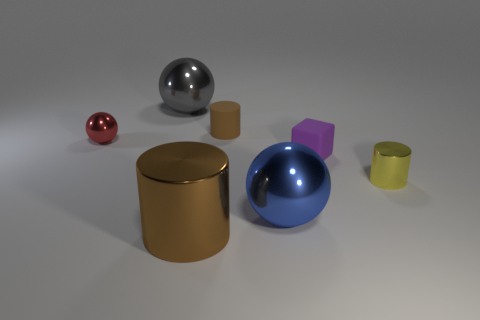Subtract all gray shiny spheres. How many spheres are left? 2 Subtract all blue spheres. How many spheres are left? 2 Subtract 1 spheres. How many spheres are left? 2 Add 2 tiny red things. How many objects exist? 9 Subtract all cylinders. How many objects are left? 4 Subtract all red balls. Subtract all brown cubes. How many balls are left? 2 Subtract all red cylinders. How many blue blocks are left? 0 Subtract all tiny rubber things. Subtract all cubes. How many objects are left? 4 Add 1 large blue things. How many large blue things are left? 2 Add 7 rubber blocks. How many rubber blocks exist? 8 